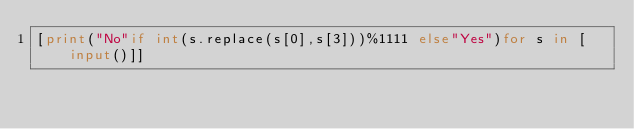Convert code to text. <code><loc_0><loc_0><loc_500><loc_500><_Python_>[print("No"if int(s.replace(s[0],s[3]))%1111 else"Yes")for s in [input()]]</code> 